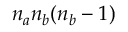<formula> <loc_0><loc_0><loc_500><loc_500>n _ { a } n _ { b } ( n _ { b } - 1 )</formula> 